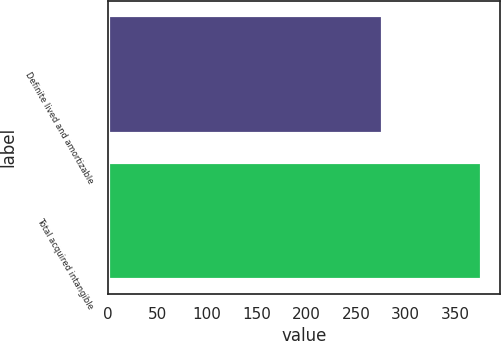Convert chart. <chart><loc_0><loc_0><loc_500><loc_500><bar_chart><fcel>Definite lived and amortizable<fcel>Total acquired intangible<nl><fcel>276<fcel>376<nl></chart> 